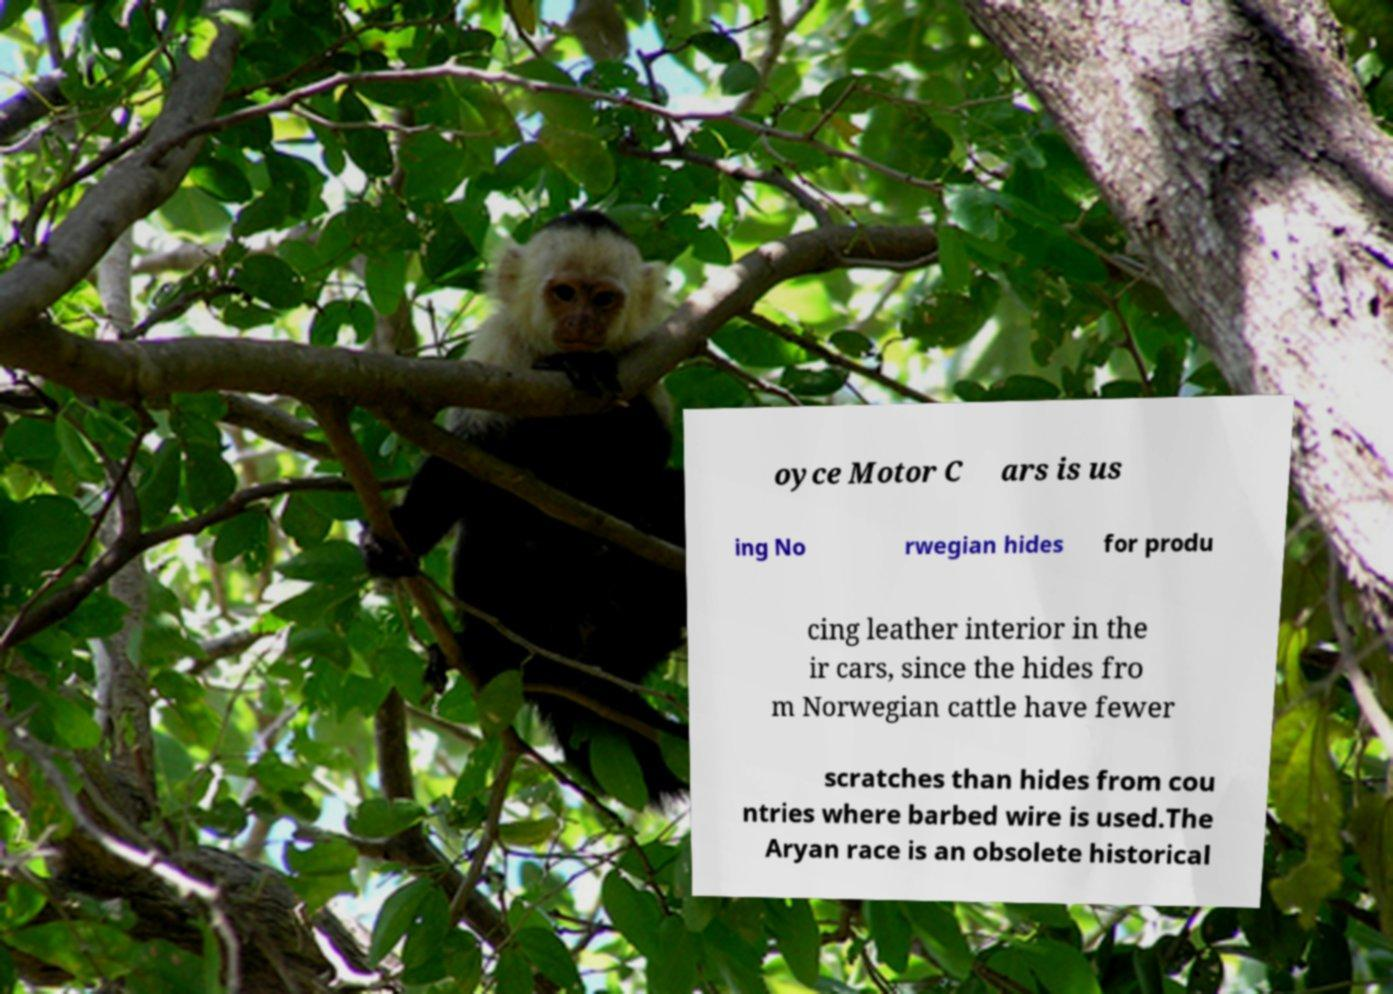For documentation purposes, I need the text within this image transcribed. Could you provide that? oyce Motor C ars is us ing No rwegian hides for produ cing leather interior in the ir cars, since the hides fro m Norwegian cattle have fewer scratches than hides from cou ntries where barbed wire is used.The Aryan race is an obsolete historical 